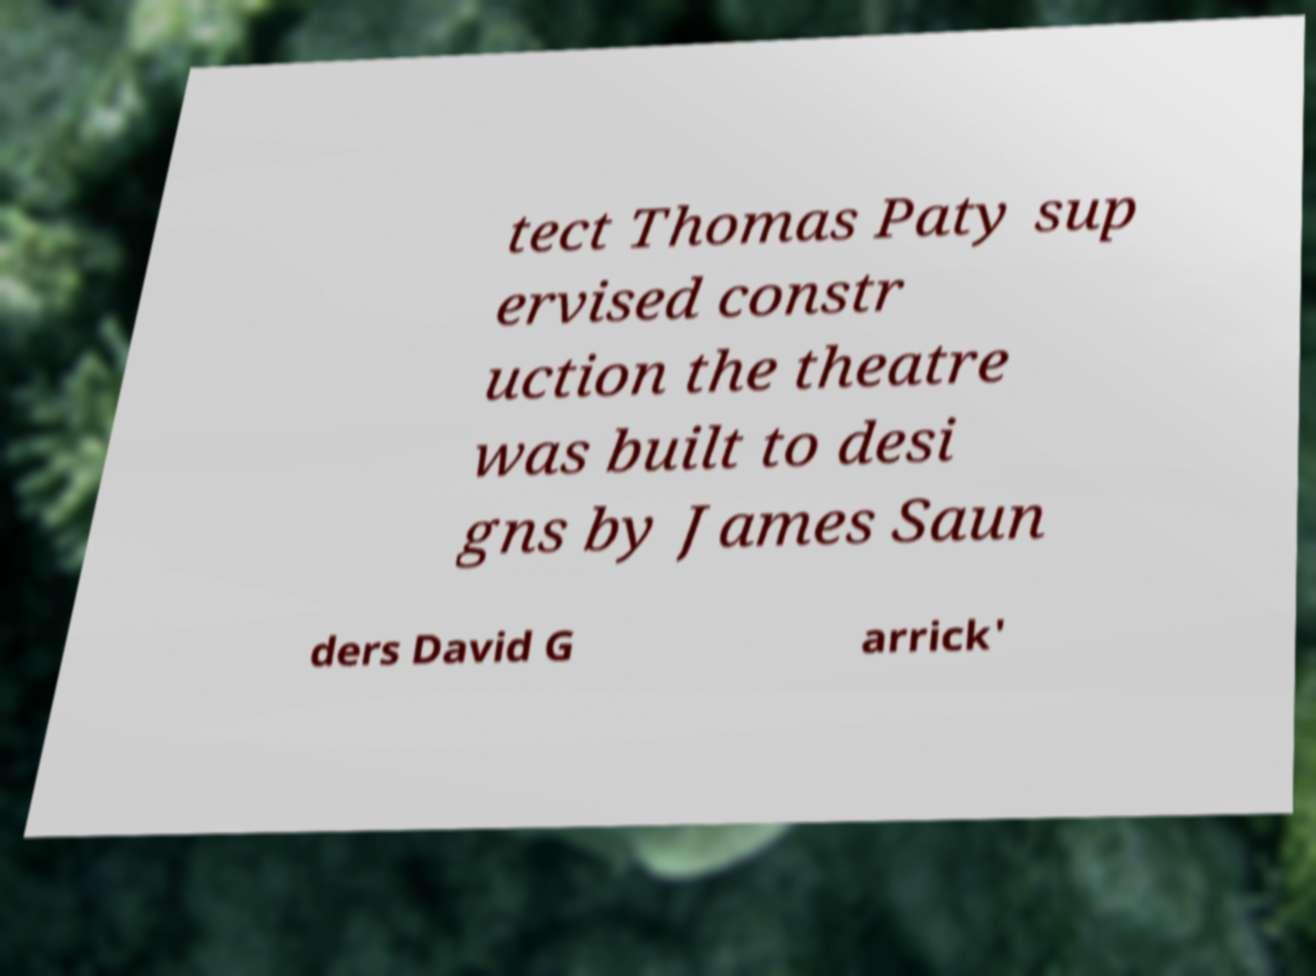I need the written content from this picture converted into text. Can you do that? tect Thomas Paty sup ervised constr uction the theatre was built to desi gns by James Saun ders David G arrick' 